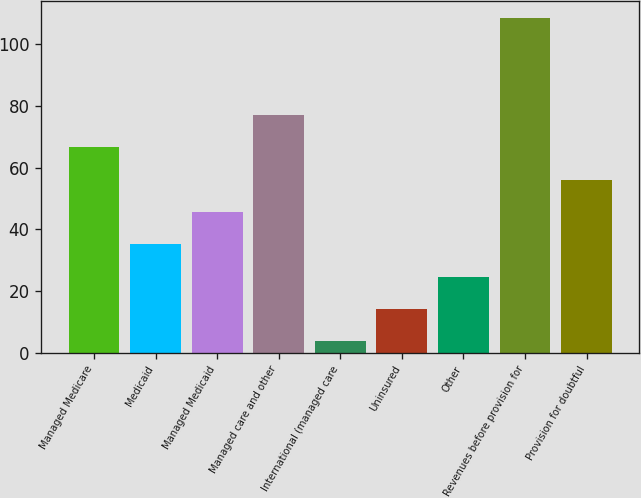Convert chart to OTSL. <chart><loc_0><loc_0><loc_500><loc_500><bar_chart><fcel>Managed Medicare<fcel>Medicaid<fcel>Managed Medicaid<fcel>Managed care and other<fcel>International (managed care<fcel>Uninsured<fcel>Other<fcel>Revenues before provision for<fcel>Provision for doubtful<nl><fcel>66.6<fcel>35.1<fcel>45.6<fcel>77.1<fcel>3.6<fcel>14.1<fcel>24.6<fcel>108.6<fcel>56.1<nl></chart> 